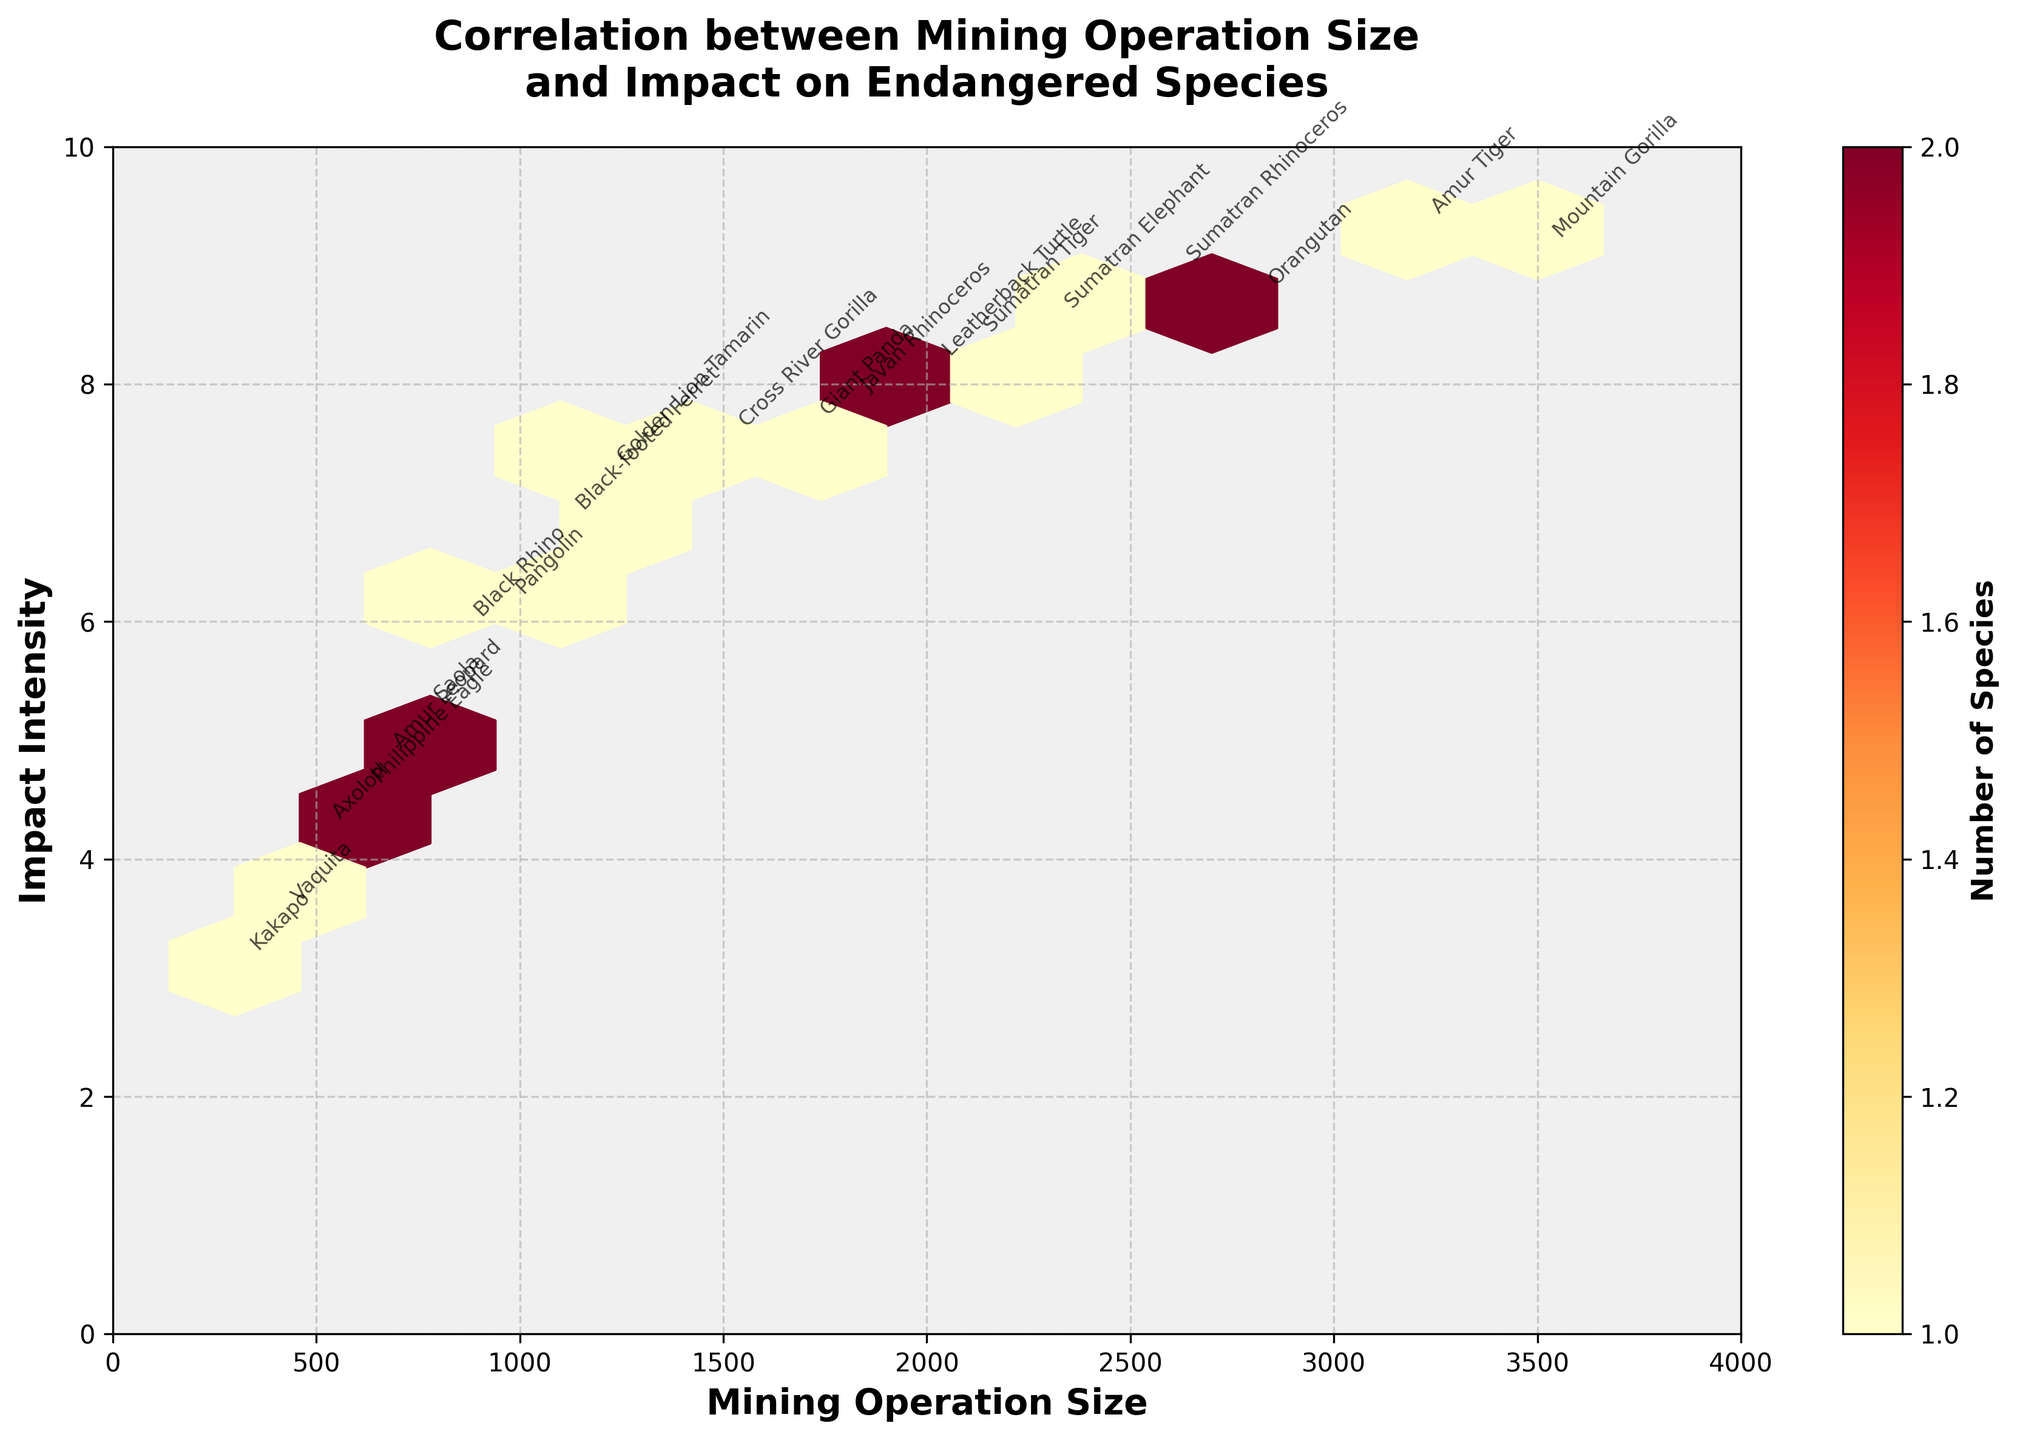What is the title of the plot? The title of the plot can be found at the top of the figure. It is phrased to indicate what the data and the relationships explored in the figure are.
Answer: Correlation between Mining Operation Size and Impact on Endangered Species How many color levels are used in the hexbin plot to represent the number of species? The color bar on the right side of the plot shows different color levels used to represent the number of species affected. You can count the distinct color segments shown in the gradient.
Answer: Multiple (ranging from light yellow to dark red) What is the range of the 'Mining Operation Size' axis? The horizontal axis (X-axis) represents Mining Operation Size. To determine its range, observe the minimum and maximum values marked along the axis.
Answer: 0 to 4000 What is the range of the 'Impact Intensity' axis? The vertical axis (Y-axis) represents Impact Intensity. To find its range, look at the minimum and maximum values marked along the axis.
Answer: 0 to 10 Which mining operation size has the highest impact intensity? By observing the plot, look for the highest point on the vertical axis (Impact Intensity) and match it to its corresponding point on the horizontal axis (Mining Operation Size).
Answer: 3200 Which species is most affected by the largest mining operation size? Find the largest value on the Mining Operation Size axis, then check the corresponding point to see which species is annotated near it.
Answer: Amur Tiger What is the most common 'Mining Operation Size' bin within the highest range of impact intensity? Look for the bins representing the highest impact intensity values (close to 10) and determine which mining operation size category (bin) is most frequently represented. Note that the color intensity will help indicate this frequency.
Answer: 2600 to 3200 Is there a mining operation size that corresponds to an impact intensity of below 5? If so, what is the mining operation size? Identify points on the plot where the vertical axis value (Impact Intensity) is below 5, and note the corresponding values on the horizontal axis (Mining Operation Size).
Answer: Yes, several mining operation sizes (e.g., 300, 400, 500, 600, 650, 750) Which species are affected when the mining operation size is between 1000 and 2000? Look at the plot to identify data points in the range of 1000 to 2000 on the X-axis, then note the species names annotated near those points.
Answer: Black-footed Ferret, Golden Lion Tamarin, Javan Rhinoceros, Pangolin, Cross River Gorilla, Giant Panda 